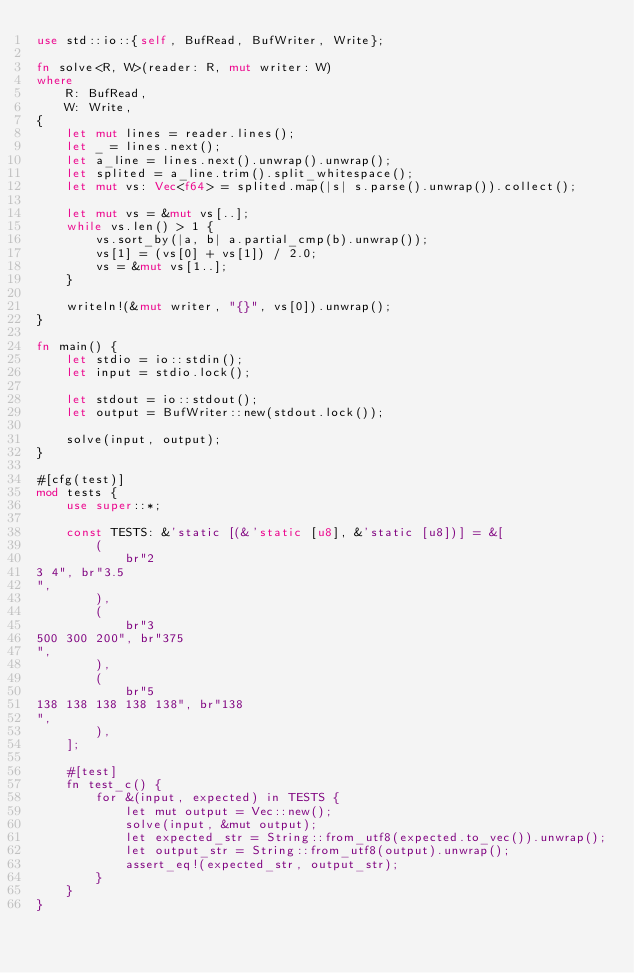Convert code to text. <code><loc_0><loc_0><loc_500><loc_500><_Rust_>use std::io::{self, BufRead, BufWriter, Write};

fn solve<R, W>(reader: R, mut writer: W)
where
    R: BufRead,
    W: Write,
{
    let mut lines = reader.lines();
    let _ = lines.next();
    let a_line = lines.next().unwrap().unwrap();
    let splited = a_line.trim().split_whitespace();
    let mut vs: Vec<f64> = splited.map(|s| s.parse().unwrap()).collect();

    let mut vs = &mut vs[..];
    while vs.len() > 1 {
        vs.sort_by(|a, b| a.partial_cmp(b).unwrap());
        vs[1] = (vs[0] + vs[1]) / 2.0;
        vs = &mut vs[1..];
    }

    writeln!(&mut writer, "{}", vs[0]).unwrap();
}

fn main() {
    let stdio = io::stdin();
    let input = stdio.lock();

    let stdout = io::stdout();
    let output = BufWriter::new(stdout.lock());

    solve(input, output);
}

#[cfg(test)]
mod tests {
    use super::*;

    const TESTS: &'static [(&'static [u8], &'static [u8])] = &[
        (
            br"2
3 4", br"3.5
",
        ),
        (
            br"3
500 300 200", br"375
",
        ),
        (
            br"5
138 138 138 138 138", br"138
",
        ),
    ];

    #[test]
    fn test_c() {
        for &(input, expected) in TESTS {
            let mut output = Vec::new();
            solve(input, &mut output);
            let expected_str = String::from_utf8(expected.to_vec()).unwrap();
            let output_str = String::from_utf8(output).unwrap();
            assert_eq!(expected_str, output_str);
        }
    }
}
</code> 